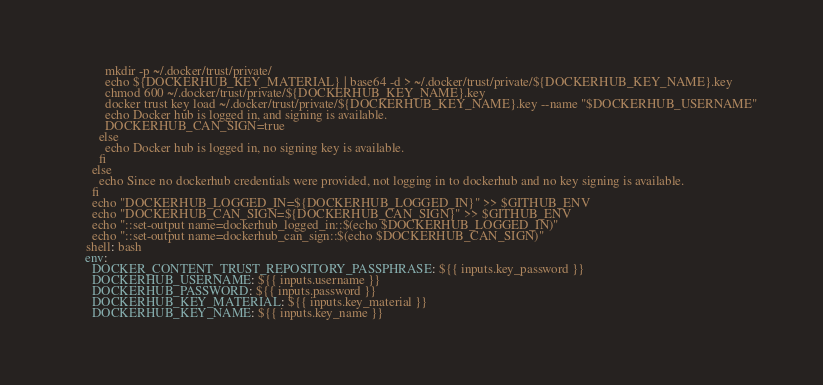<code> <loc_0><loc_0><loc_500><loc_500><_YAML_>            mkdir -p ~/.docker/trust/private/
            echo ${DOCKERHUB_KEY_MATERIAL} | base64 -d > ~/.docker/trust/private/${DOCKERHUB_KEY_NAME}.key
            chmod 600 ~/.docker/trust/private/${DOCKERHUB_KEY_NAME}.key
            docker trust key load ~/.docker/trust/private/${DOCKERHUB_KEY_NAME}.key --name "$DOCKERHUB_USERNAME"
            echo Docker hub is logged in, and signing is available.
            DOCKERHUB_CAN_SIGN=true
          else
            echo Docker hub is logged in, no signing key is available.
          fi
        else
          echo Since no dockerhub credentials were provided, not logging in to dockerhub and no key signing is available.
        fi
        echo "DOCKERHUB_LOGGED_IN=${DOCKERHUB_LOGGED_IN}" >> $GITHUB_ENV
        echo "DOCKERHUB_CAN_SIGN=${DOCKERHUB_CAN_SIGN}" >> $GITHUB_ENV
        echo "::set-output name=dockerhub_logged_in::$(echo $DOCKERHUB_LOGGED_IN)"
        echo "::set-output name=dockerhub_can_sign::$(echo $DOCKERHUB_CAN_SIGN)"
      shell: bash
      env:
        DOCKER_CONTENT_TRUST_REPOSITORY_PASSPHRASE: ${{ inputs.key_password }}
        DOCKERHUB_USERNAME: ${{ inputs.username }}
        DOCKERHUB_PASSWORD: ${{ inputs.password }}
        DOCKERHUB_KEY_MATERIAL: ${{ inputs.key_material }}
        DOCKERHUB_KEY_NAME: ${{ inputs.key_name }}
</code> 